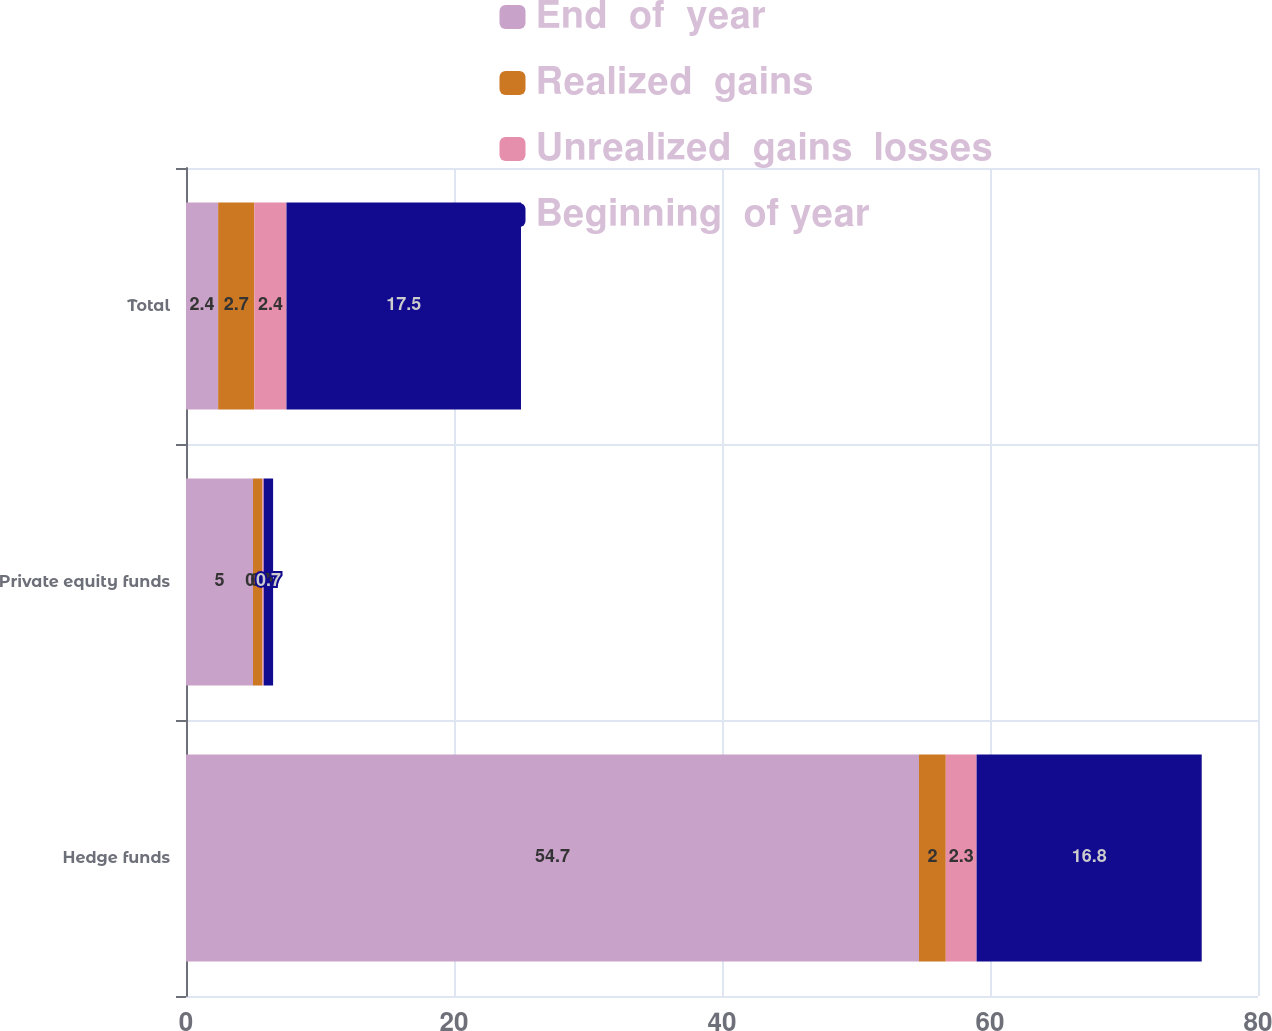Convert chart. <chart><loc_0><loc_0><loc_500><loc_500><stacked_bar_chart><ecel><fcel>Hedge funds<fcel>Private equity funds<fcel>Total<nl><fcel>End  of  year<fcel>54.7<fcel>5<fcel>2.4<nl><fcel>Realized  gains<fcel>2<fcel>0.7<fcel>2.7<nl><fcel>Unrealized  gains  losses<fcel>2.3<fcel>0.1<fcel>2.4<nl><fcel>Beginning  of year<fcel>16.8<fcel>0.7<fcel>17.5<nl></chart> 